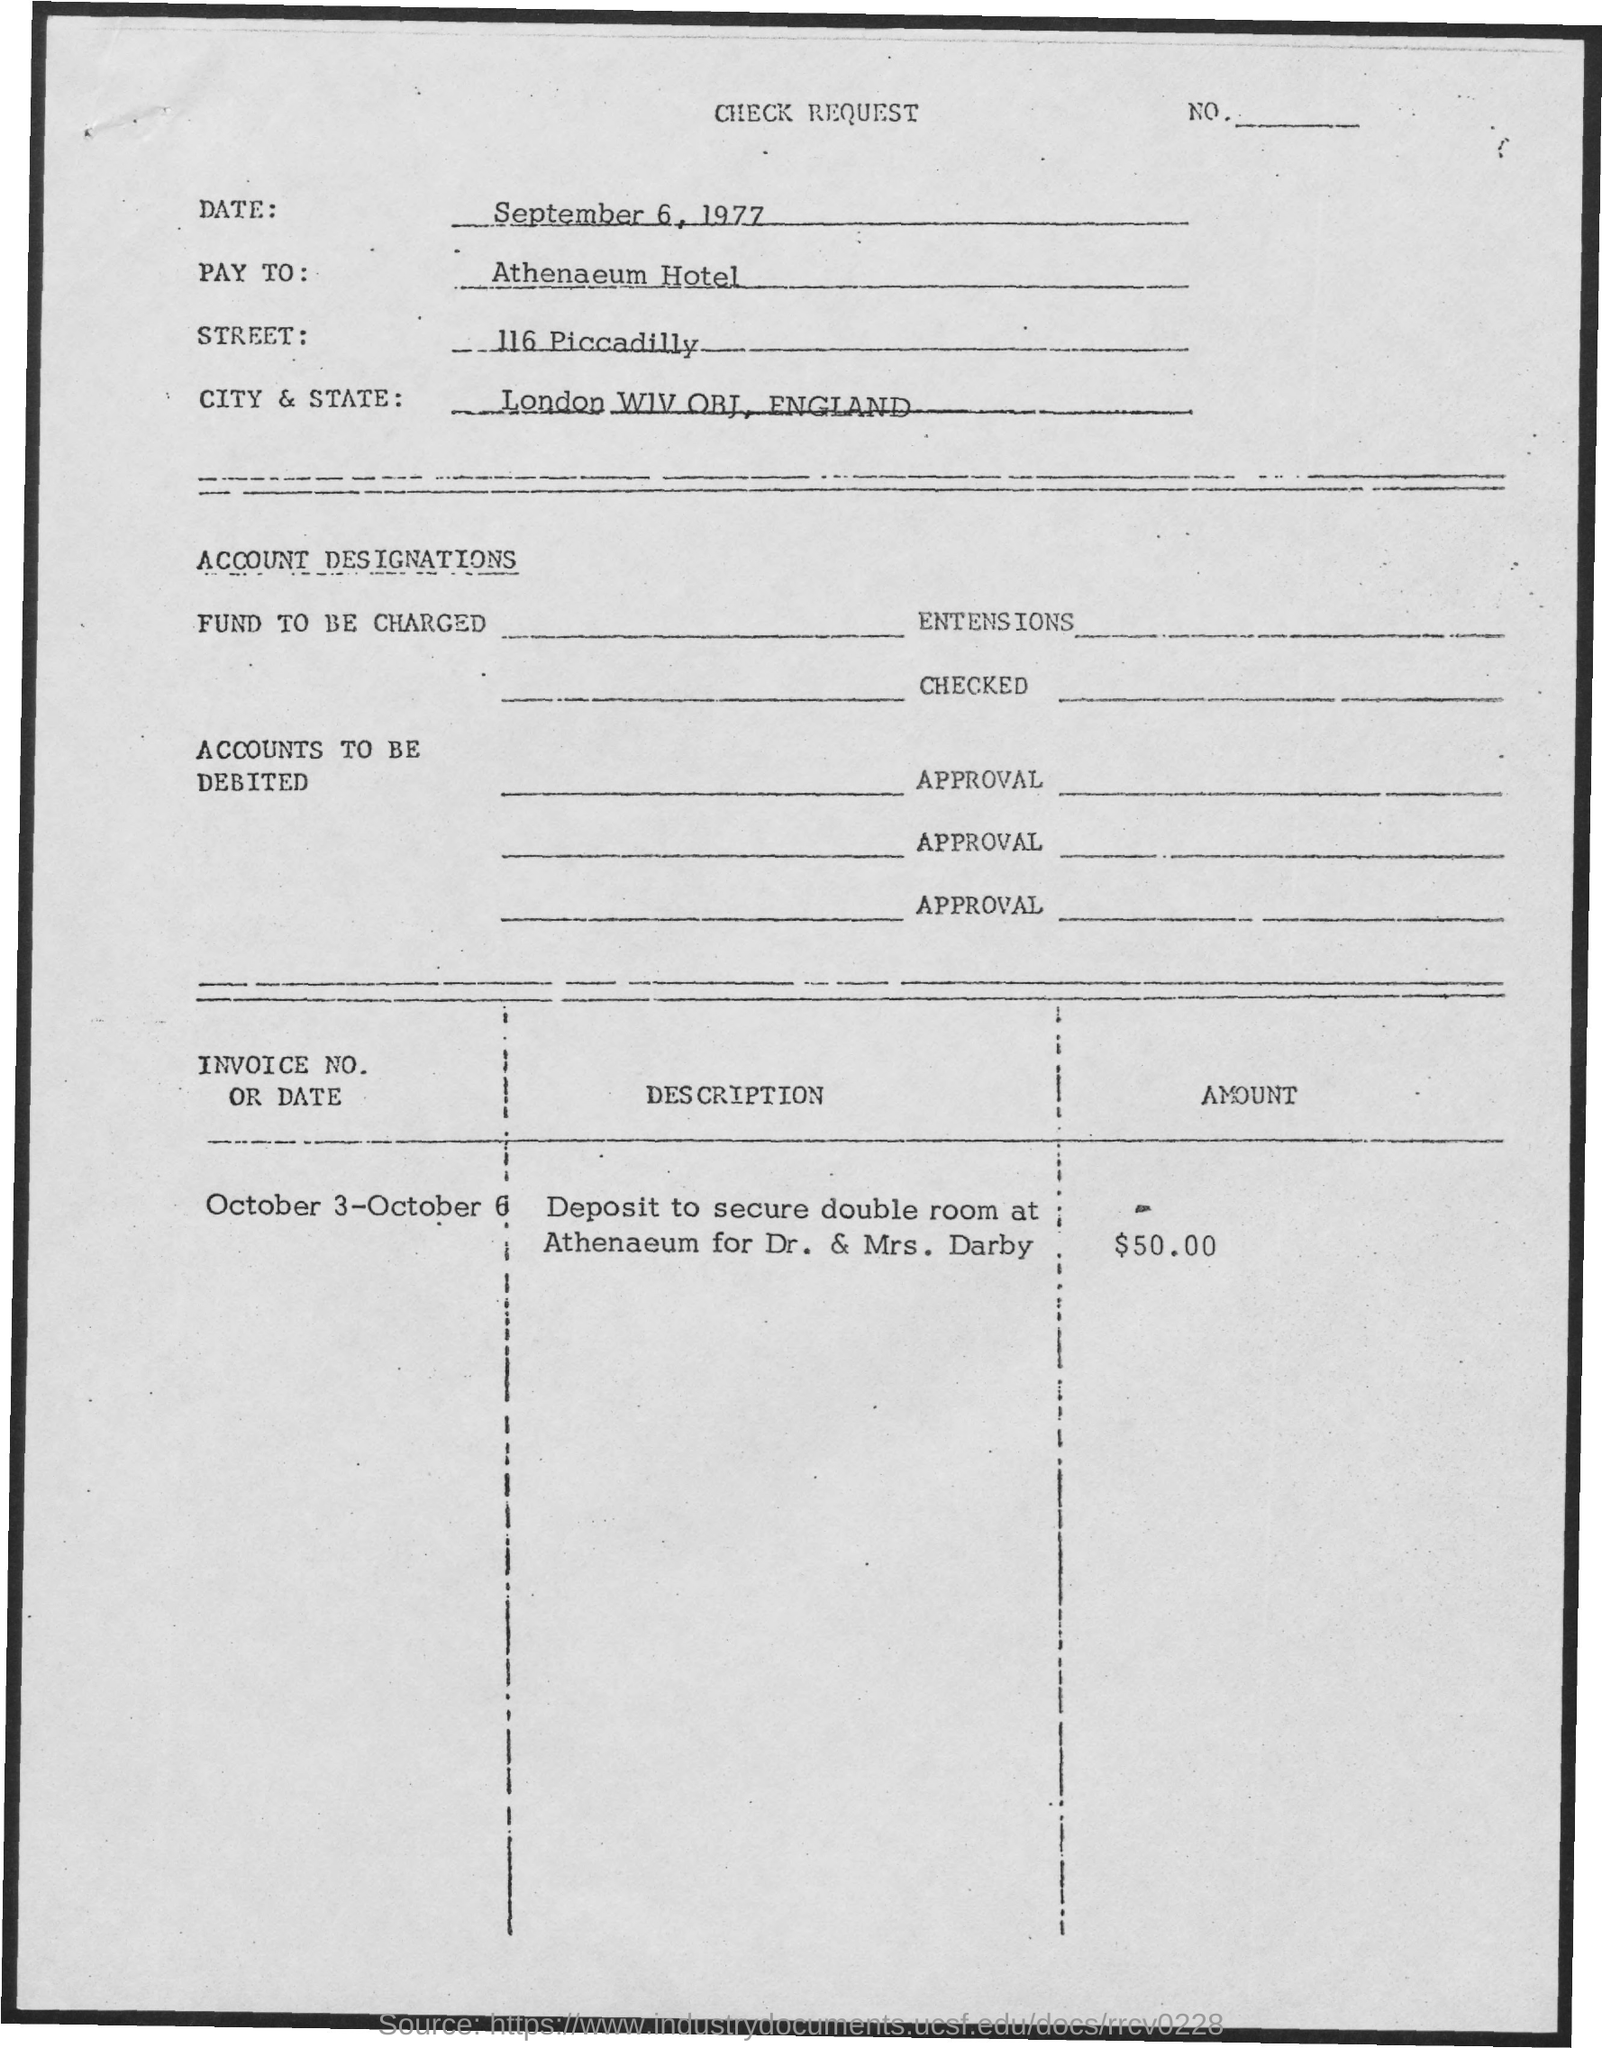What is the Date?
Offer a terse response. September 6, 1977. Who is the "Pay To"?
Offer a terse response. Athenaeum Hotel. What is the street?
Give a very brief answer. 116 Piccadilly. What is the Amount?
Ensure brevity in your answer.  $50.00. 